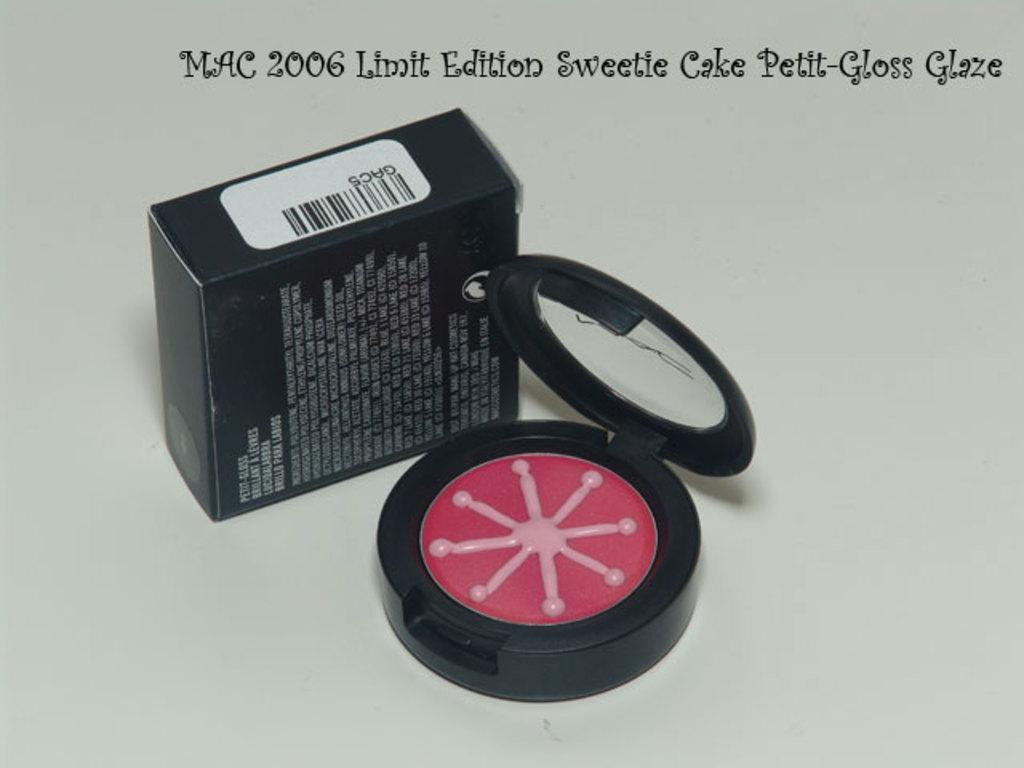What is under the barcode?
Make the answer very short. Gac5. 